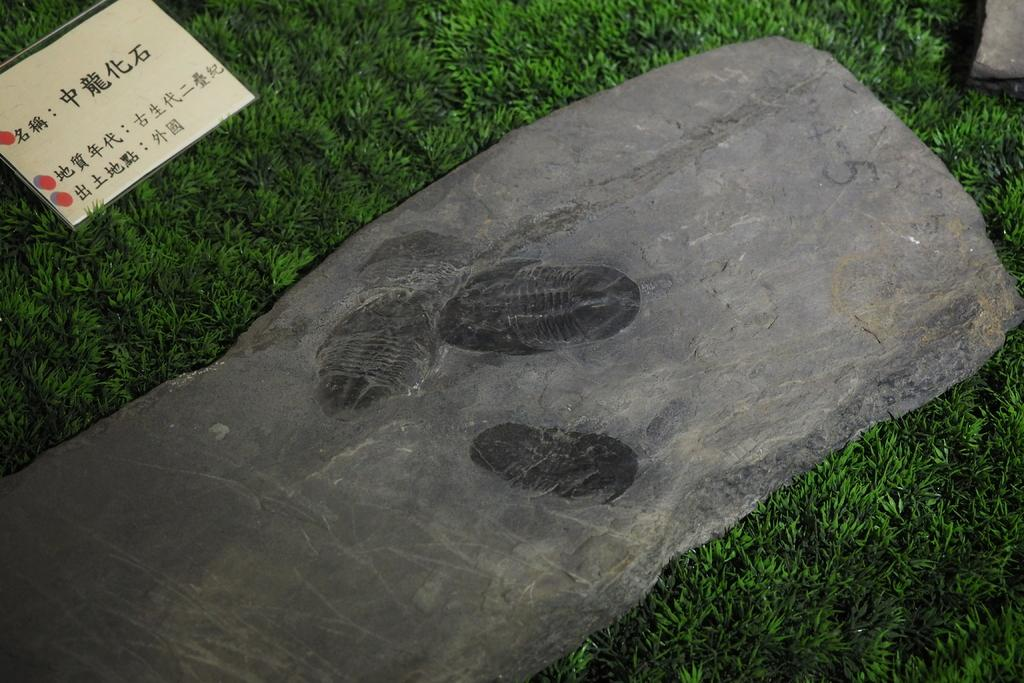What type of terrain is visible in the image? There is a grassy land in the image. What objects can be seen on the grassy land? There are two rocks in the image. Is there any additional information provided in the image? Yes, there is a descriptive board in the image. Can you tell me what color the deer's sweater is in the image? There is no deer or sweater present in the image. 